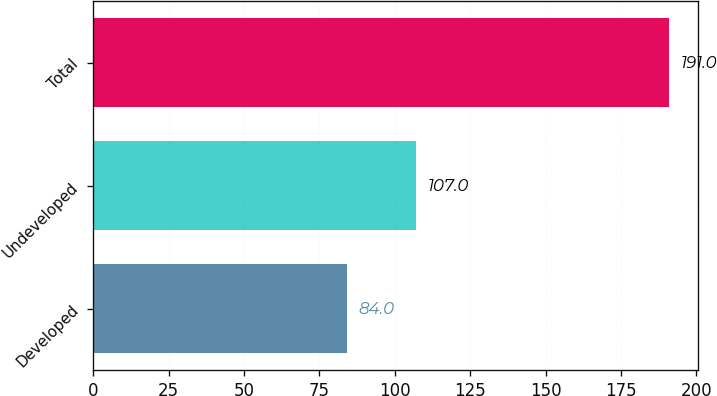Convert chart to OTSL. <chart><loc_0><loc_0><loc_500><loc_500><bar_chart><fcel>Developed<fcel>Undeveloped<fcel>Total<nl><fcel>84<fcel>107<fcel>191<nl></chart> 